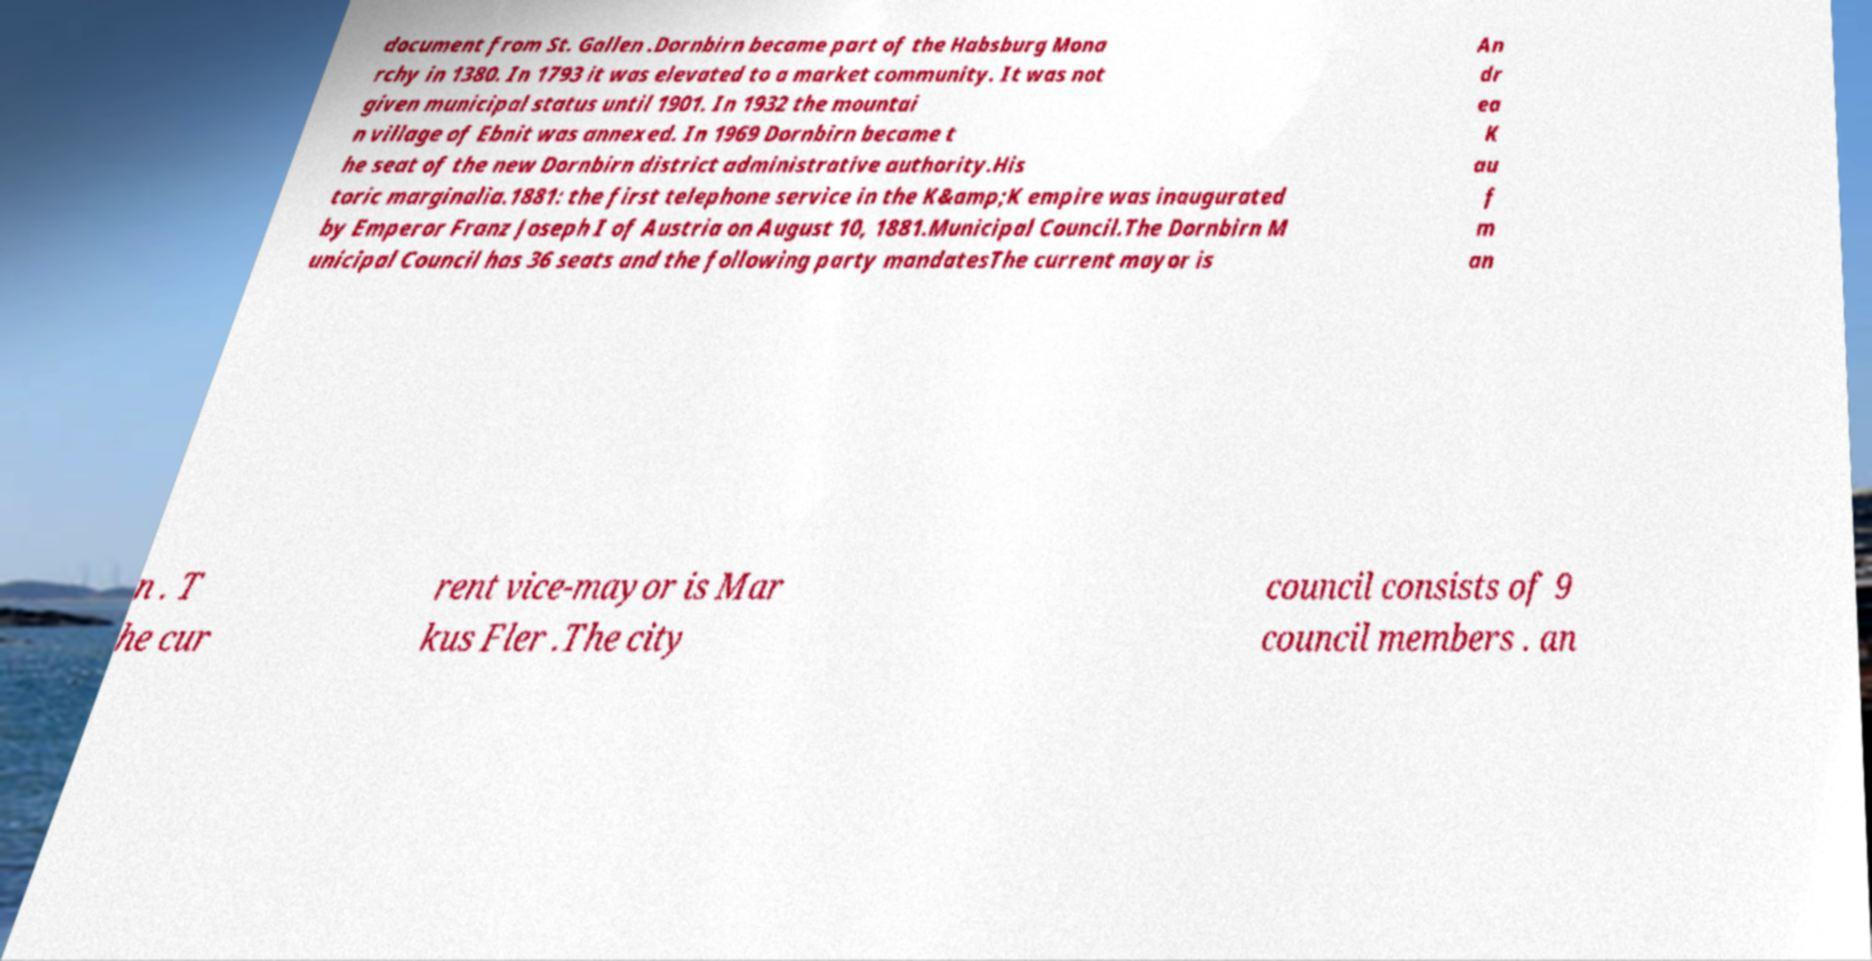Could you assist in decoding the text presented in this image and type it out clearly? document from St. Gallen .Dornbirn became part of the Habsburg Mona rchy in 1380. In 1793 it was elevated to a market community. It was not given municipal status until 1901. In 1932 the mountai n village of Ebnit was annexed. In 1969 Dornbirn became t he seat of the new Dornbirn district administrative authority.His toric marginalia.1881: the first telephone service in the K&amp;K empire was inaugurated by Emperor Franz Joseph I of Austria on August 10, 1881.Municipal Council.The Dornbirn M unicipal Council has 36 seats and the following party mandatesThe current mayor is An dr ea K au f m an n . T he cur rent vice-mayor is Mar kus Fler .The city council consists of 9 council members . an 